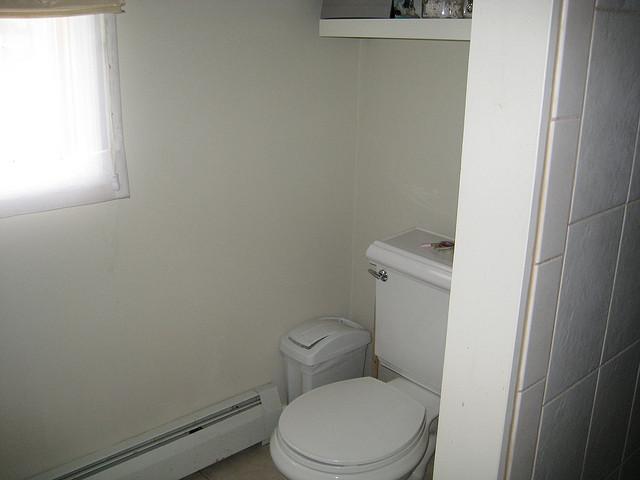How many people are standing outside the train in the image?
Give a very brief answer. 0. 